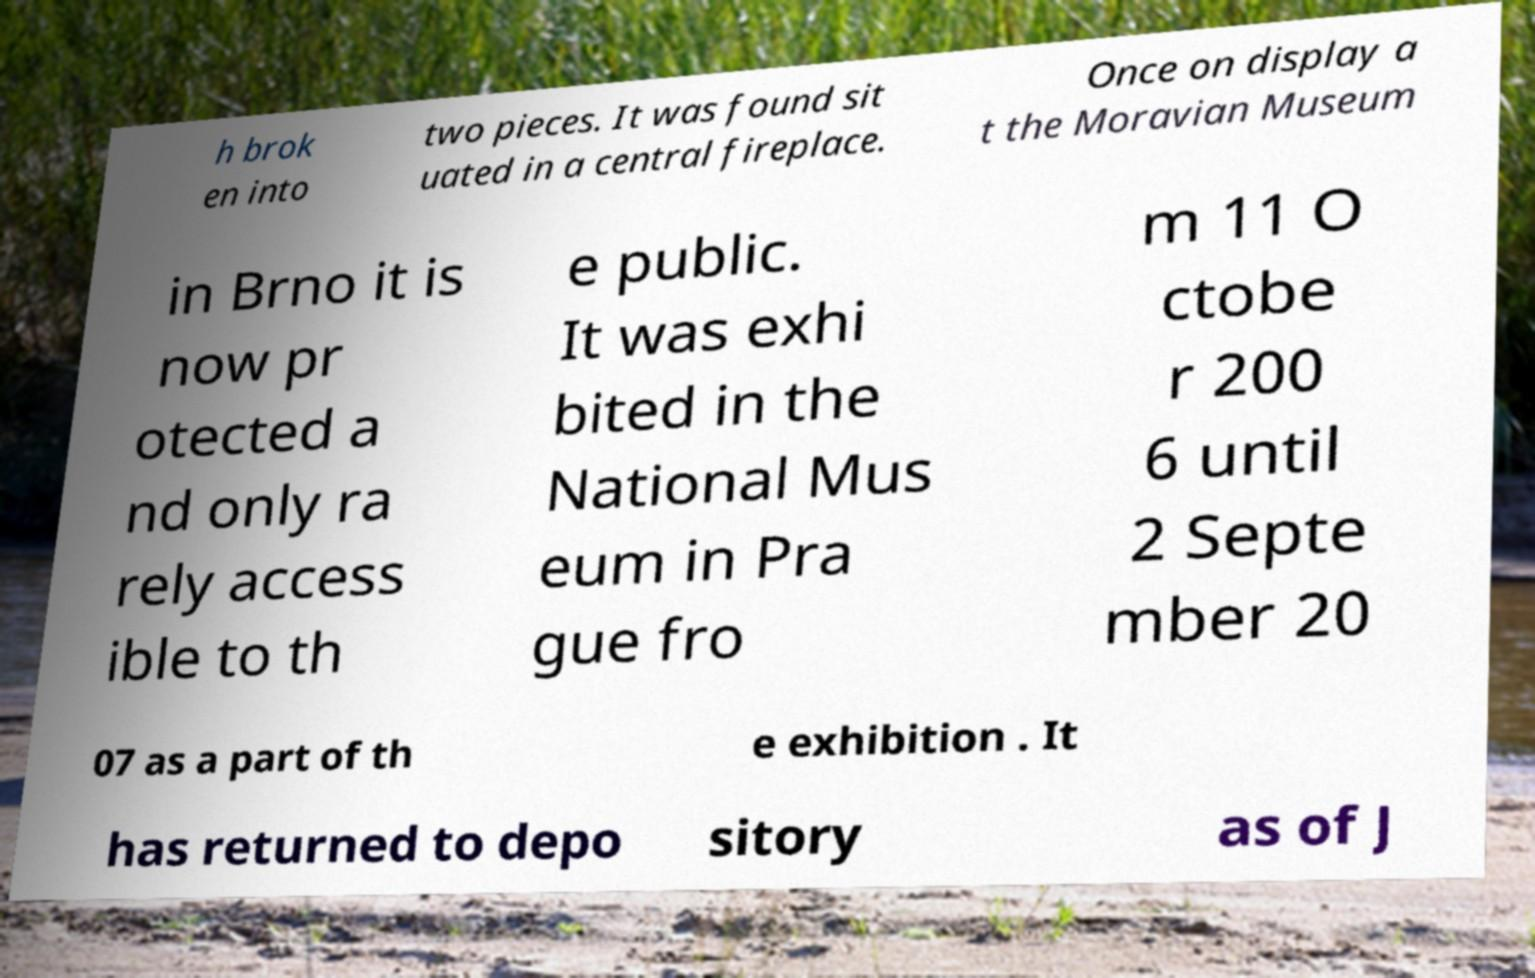Please identify and transcribe the text found in this image. h brok en into two pieces. It was found sit uated in a central fireplace. Once on display a t the Moravian Museum in Brno it is now pr otected a nd only ra rely access ible to th e public. It was exhi bited in the National Mus eum in Pra gue fro m 11 O ctobe r 200 6 until 2 Septe mber 20 07 as a part of th e exhibition . It has returned to depo sitory as of J 